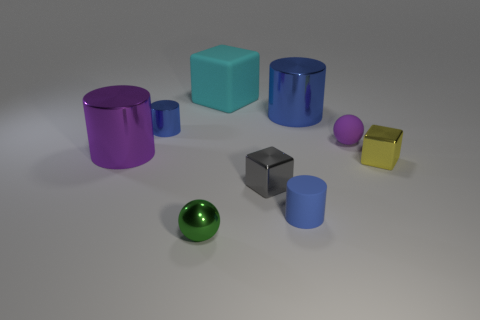Subtract all blue cylinders. How many were subtracted if there are1blue cylinders left? 2 Subtract all cyan balls. How many blue cylinders are left? 3 Add 1 blue objects. How many objects exist? 10 Subtract all blocks. How many objects are left? 6 Subtract all blue balls. Subtract all large purple metal cylinders. How many objects are left? 8 Add 8 large purple objects. How many large purple objects are left? 9 Add 3 tiny purple balls. How many tiny purple balls exist? 4 Subtract 1 yellow blocks. How many objects are left? 8 